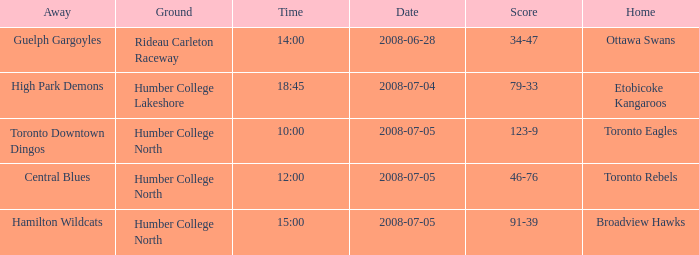What is the Date with a Time that is 18:45? 2008-07-04. Write the full table. {'header': ['Away', 'Ground', 'Time', 'Date', 'Score', 'Home'], 'rows': [['Guelph Gargoyles', 'Rideau Carleton Raceway', '14:00', '2008-06-28', '34-47', 'Ottawa Swans'], ['High Park Demons', 'Humber College Lakeshore', '18:45', '2008-07-04', '79-33', 'Etobicoke Kangaroos'], ['Toronto Downtown Dingos', 'Humber College North', '10:00', '2008-07-05', '123-9', 'Toronto Eagles'], ['Central Blues', 'Humber College North', '12:00', '2008-07-05', '46-76', 'Toronto Rebels'], ['Hamilton Wildcats', 'Humber College North', '15:00', '2008-07-05', '91-39', 'Broadview Hawks']]} 